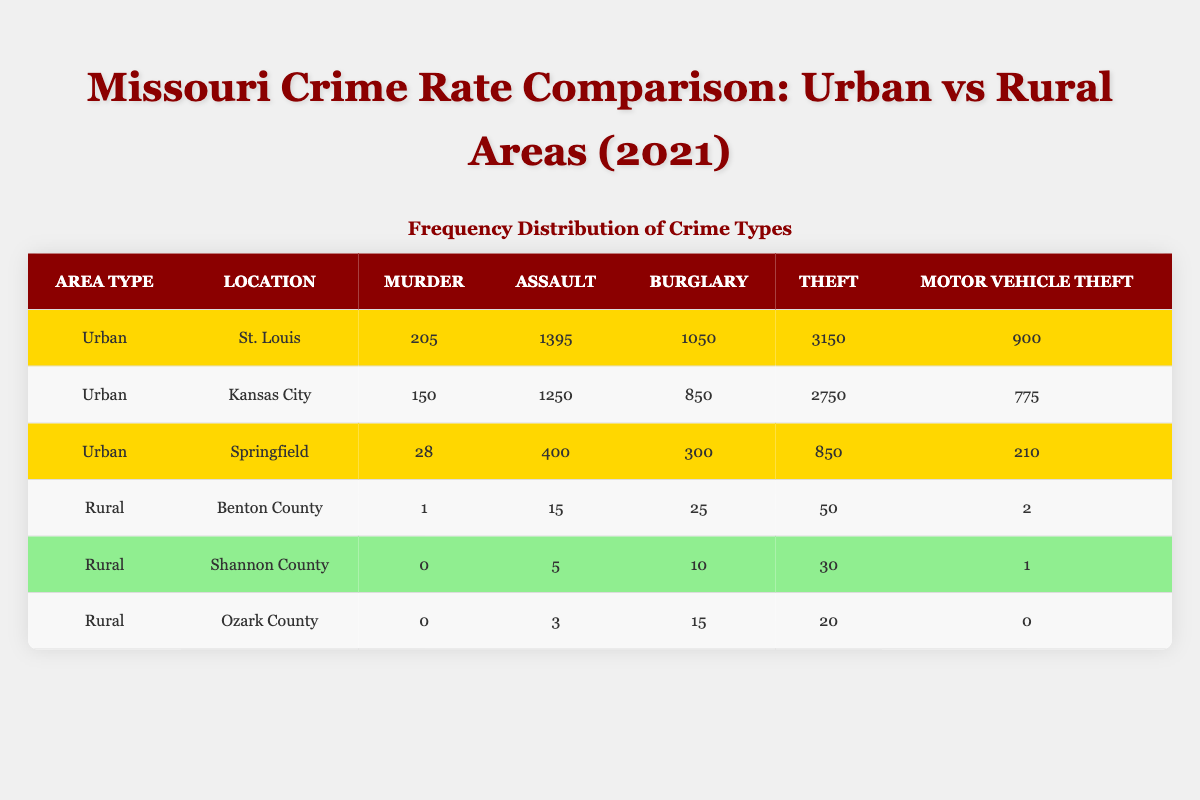What is the total number of murders reported in urban areas? To find the total number of murders in urban areas, I will sum the murders from each urban location: St. Louis (205) + Kansas City (150) + Springfield (28) = 383.
Answer: 383 Which city has the highest number of thefts in urban areas? By looking at the theft column, St. Louis has 3150 thefts, Kansas City has 2750 thefts, and Springfield has 850 thefts. Comparing these values, St. Louis has the highest.
Answer: St. Louis True or False: The total number of motor vehicle thefts in rural areas is less than in urban areas. First, I will sum the motor vehicle thefts in rural areas: Benton County (2) + Shannon County (1) + Ozark County (0) = 3. Then I compare this with the total for urban areas: St. Louis (900) + Kansas City (775) + Springfield (210) = 1885. Since 3 < 1885, the statement is true.
Answer: True What is the average number of assaults in urban areas? To find the average number of assaults, first sum the assaults: St. Louis (1395) + Kansas City (1250) + Springfield (400) = 3045. Then divide by the number of urban locations (3): 3045 / 3 = 1015.
Answer: 1015 What is the difference in the number of burglaries between the city with the highest and lowest burglaries? First, identify the burglaries: St. Louis (1050), Kansas City (850), Springfield (300). The highest is St. Louis (1050) and the lowest is Springfield (300). The difference is 1050 - 300 = 750.
Answer: 750 What is the total number of assaults across all areas? To calculate the total assaults, sum the assaults from both urban and rural areas: (1395 + 1250 + 400) for urban gives 3045, and for rural: (15 + 5 + 3) gives 23. Therefore, total assaults are 3045 + 23 = 3068.
Answer: 3068 Which county has the lowest number of burglaries? In the burglary column, Benton County has 25, Shannon County has 10, and Ozark County has 15. The lowest number is from Shannon County, which has 10 burglaries.
Answer: Shannon County How many total theft incidents occurred in both urban and rural areas combined? I will sum the total thefts: from urban areas: St. Louis (3150) + Kansas City (2750) + Springfield (850) = 6750. For rural areas: Benton County (50) + Shannon County (30) + Ozark County (20) = 100. Therefore, total thefts are 6750 + 100 = 6850.
Answer: 6850 